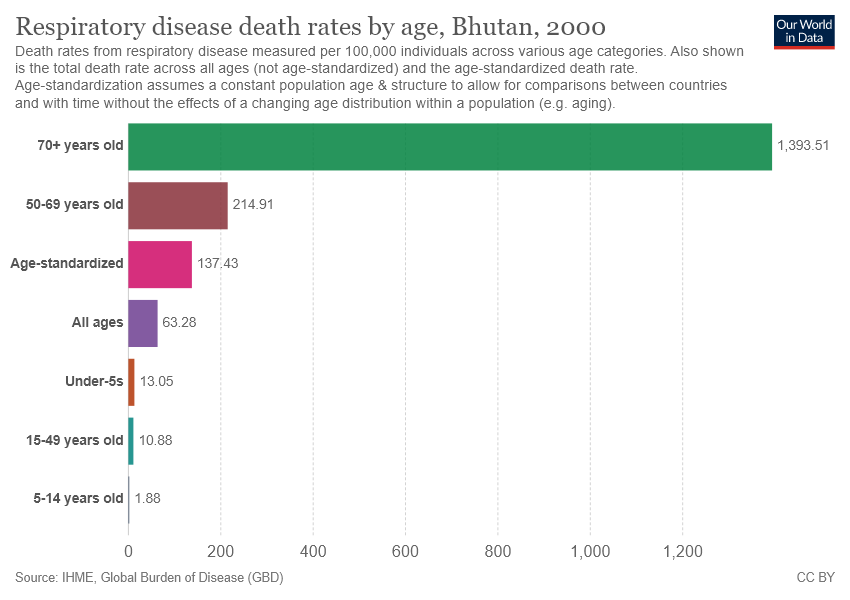Identify some key points in this picture. The value of the green bar is 1393.51. The average value of the last two bars in the chart is 6.38. 